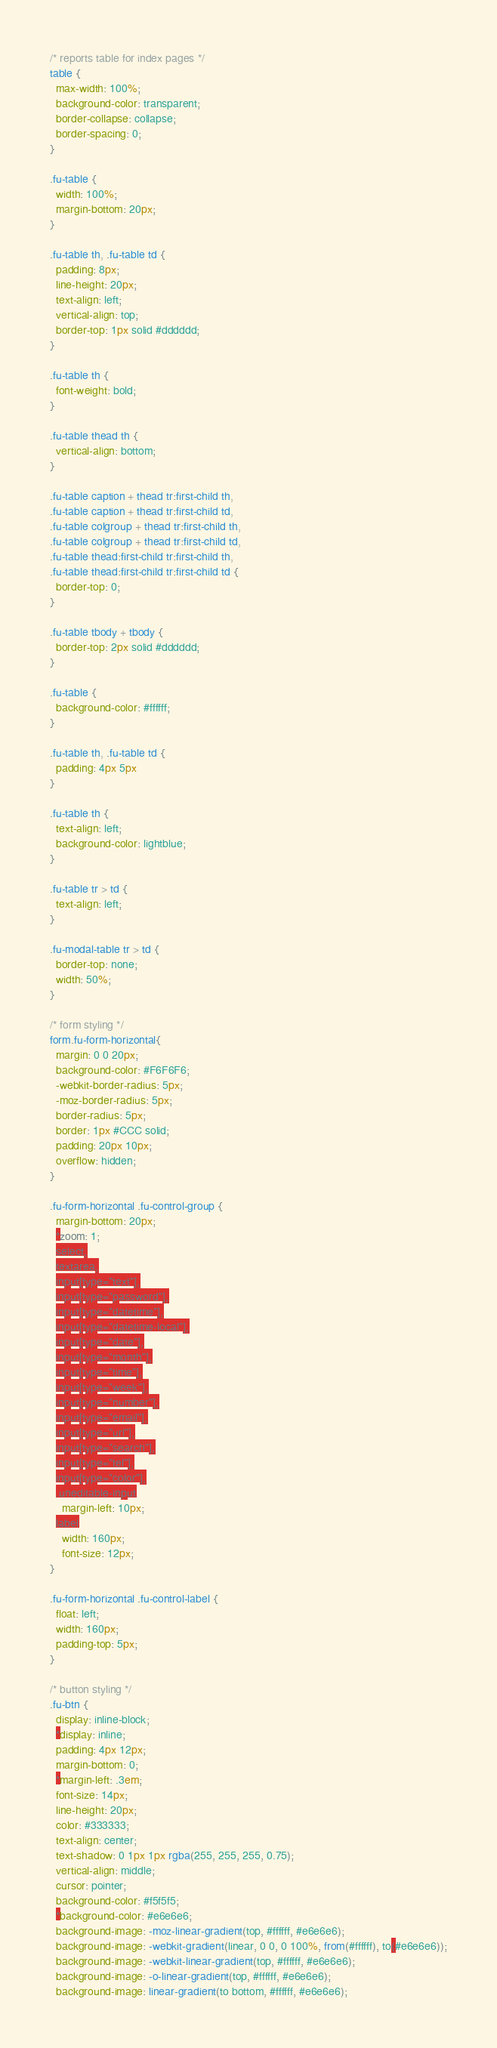<code> <loc_0><loc_0><loc_500><loc_500><_CSS_>/* reports table for index pages */
table {
  max-width: 100%;
  background-color: transparent;
  border-collapse: collapse;
  border-spacing: 0;
}

.fu-table {
  width: 100%;
  margin-bottom: 20px;
}

.fu-table th, .fu-table td {
  padding: 8px;
  line-height: 20px;
  text-align: left;
  vertical-align: top;
  border-top: 1px solid #dddddd;
}

.fu-table th {
  font-weight: bold;
}

.fu-table thead th {
  vertical-align: bottom;
}

.fu-table caption + thead tr:first-child th,
.fu-table caption + thead tr:first-child td,
.fu-table colgroup + thead tr:first-child th,
.fu-table colgroup + thead tr:first-child td,
.fu-table thead:first-child tr:first-child th,
.fu-table thead:first-child tr:first-child td {
  border-top: 0;
}

.fu-table tbody + tbody {
  border-top: 2px solid #dddddd;
}

.fu-table {
  background-color: #ffffff;
}

.fu-table th, .fu-table td {
  padding: 4px 5px
}

.fu-table th {
  text-align: left;
  background-color: lightblue;
}

.fu-table tr > td {
  text-align: left;
}

.fu-modal-table tr > td {
  border-top: none;
  width: 50%;
}

/* form styling */
form.fu-form-horizontal{
  margin: 0 0 20px;
  background-color: #F6F6F6;
  -webkit-border-radius: 5px;
  -moz-border-radius: 5px;
  border-radius: 5px;
  border: 1px #CCC solid;
  padding: 20px 10px;
  overflow: hidden;
}

.fu-form-horizontal .fu-control-group {
  margin-bottom: 20px;
  *zoom: 1;
  select,
  textarea,
  input[type="text"],
  input[type="password"],
  input[type="datetime"],
  input[type="datetime-local"],
  input[type="date"],
  input[type="month"],
  input[type="time"],
  input[type="week"],
  input[type="number"],
  input[type="email"],
  input[type="url"],
  input[type="search"],
  input[type="tel"],
  input[type="color"],
  .uneditable-input
    margin-left: 10px;
  label
    width: 160px;
    font-size: 12px;
}

.fu-form-horizontal .fu-control-label {
  float: left;
  width: 160px;
  padding-top: 5px;
}

/* button styling */
.fu-btn {
  display: inline-block;
  *display: inline;
  padding: 4px 12px;
  margin-bottom: 0;
  *margin-left: .3em;
  font-size: 14px;
  line-height: 20px;
  color: #333333;
  text-align: center;
  text-shadow: 0 1px 1px rgba(255, 255, 255, 0.75);
  vertical-align: middle;
  cursor: pointer;
  background-color: #f5f5f5;
  *background-color: #e6e6e6;
  background-image: -moz-linear-gradient(top, #ffffff, #e6e6e6);
  background-image: -webkit-gradient(linear, 0 0, 0 100%, from(#ffffff), to(#e6e6e6));
  background-image: -webkit-linear-gradient(top, #ffffff, #e6e6e6);
  background-image: -o-linear-gradient(top, #ffffff, #e6e6e6);
  background-image: linear-gradient(to bottom, #ffffff, #e6e6e6);</code> 